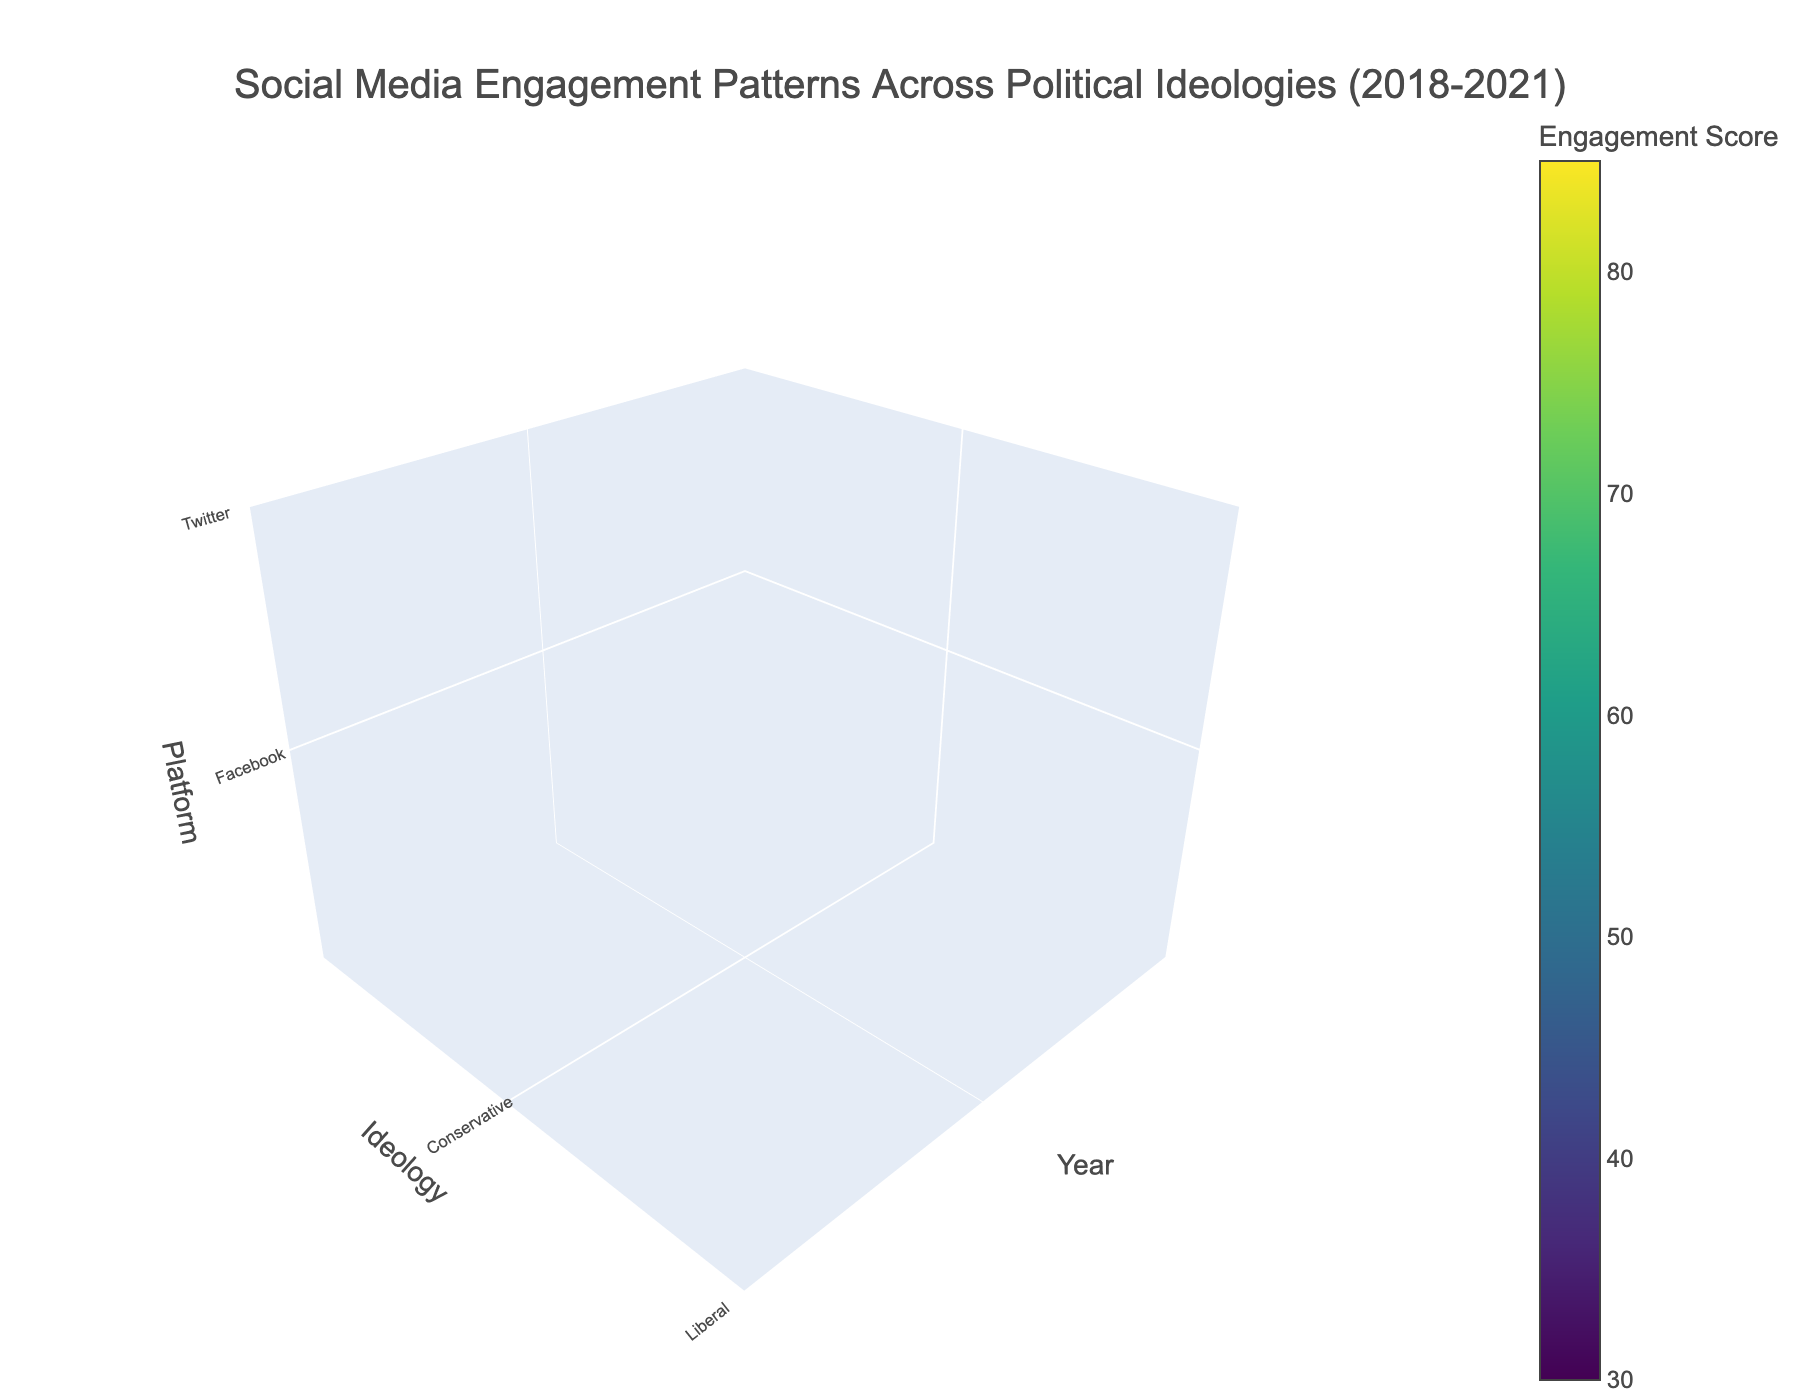What is the title of the figure? The title of the figure is located at the top center and provides an overarching description of the visualized data.
Answer: Social Media Engagement Patterns Across Political Ideologies (2018-2021) What are the three platforms shown on the z-axis? Identify the platforms by looking at the labels on the z-axis.
Answer: Facebook, Twitter, Reddit Which political ideology had the highest engagement score on Twitter in 2021? Look at the 2021 section of the plot, focus on the Twitter engagement scores, and identify the highest value.
Answer: Liberal Which political ideology's engagement score increased the most on Facebook from 2018 to 2021? For each ideology, subtract the 2018 engagement score from the 2021 score on Facebook and compare the differences.
Answer: Conservative What's the average engagement score across all ideologies on Reddit in 2020? Sum the engagement scores for all ideologies on Reddit in 2020 and then divide by the number of ideologies.
Answer: (55 + 68 + 48) / 3 = 57 Which year has the highest overall engagement score across all platforms and ideologies? Add up all engagement scores for each year and compare the totals to find the highest one.
Answer: 2021 Is the engagement score for Conservative users on Twitter higher or lower than that for Liberal users on Facebook in 2020? Directly compare the engagement scores for Conservative users on Twitter to Liberal users on Facebook in 2020.
Answer: Higher What is the trend of engagement scores on Reddit for Moderates from 2018 to 2021? Observe the engagement scores for Moderates on Reddit year by year from 2018 to 2021 to determine the trend.
Answer: Increasing How do the engagement scores for all three political ideologies compare on Facebook over the four years? Compare the engagement scores for each ideology on Facebook from 2018 to 2021 by analyzing each year's values.
Answer: Conservative scores generally increase, Liberal scores also generally increase, Moderate scores increase slowly What is the difference in engagement scores on Twitter between Conservatives and Liberals in 2021? Subtract the engagement score of Liberal users on Twitter from that of Conservative users on Twitter in 2021.
Answer: 78 - 80 = -2 